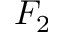Convert formula to latex. <formula><loc_0><loc_0><loc_500><loc_500>F _ { 2 }</formula> 